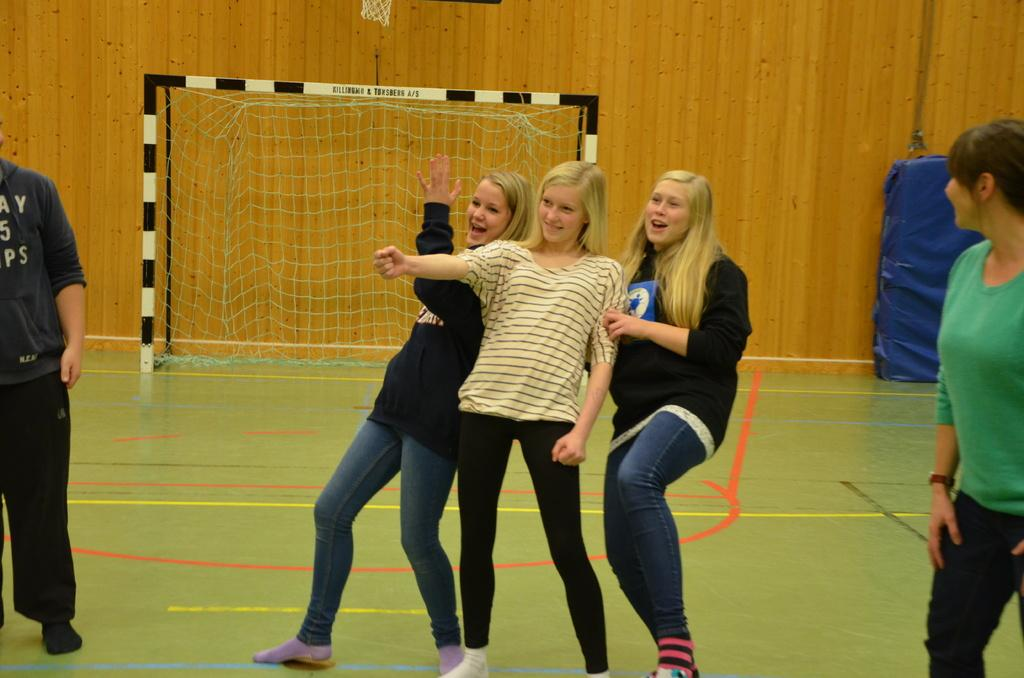How many people are present in the image? There are five persons standing in the image. What can be seen in the background of the image? There is a wall in the background of the image. What is the main object in the middle of the image? There is a goal post in the middle of the image. What type of animal is sitting on the basket in the image? There is no basket or animal present in the image. What is the texture of the wax in the image? There is no wax present in the image. 